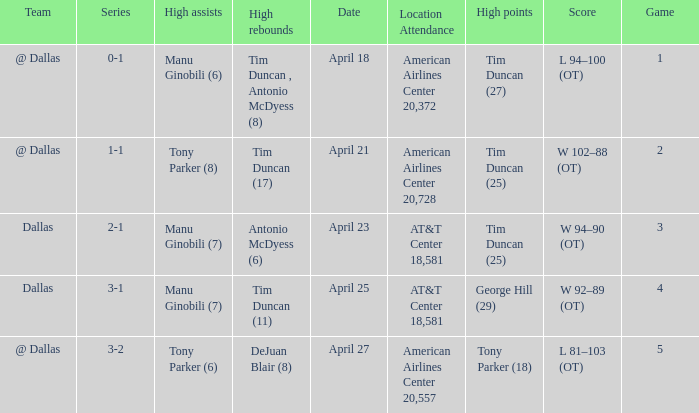When 0-1 is the series who has the highest amount of assists? Manu Ginobili (6). 